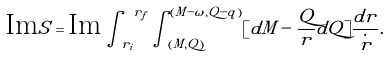<formula> <loc_0><loc_0><loc_500><loc_500>\text {Im} S = \text {Im} \int \nolimits _ { r _ { i } } ^ { \ r _ { f } } \int _ { ( M , Q ) } ^ { ( M - \omega , Q - q ) } [ d M - \frac { Q } { r } d Q ] \frac { d r } { \overset { \cdot } { r } } .</formula> 